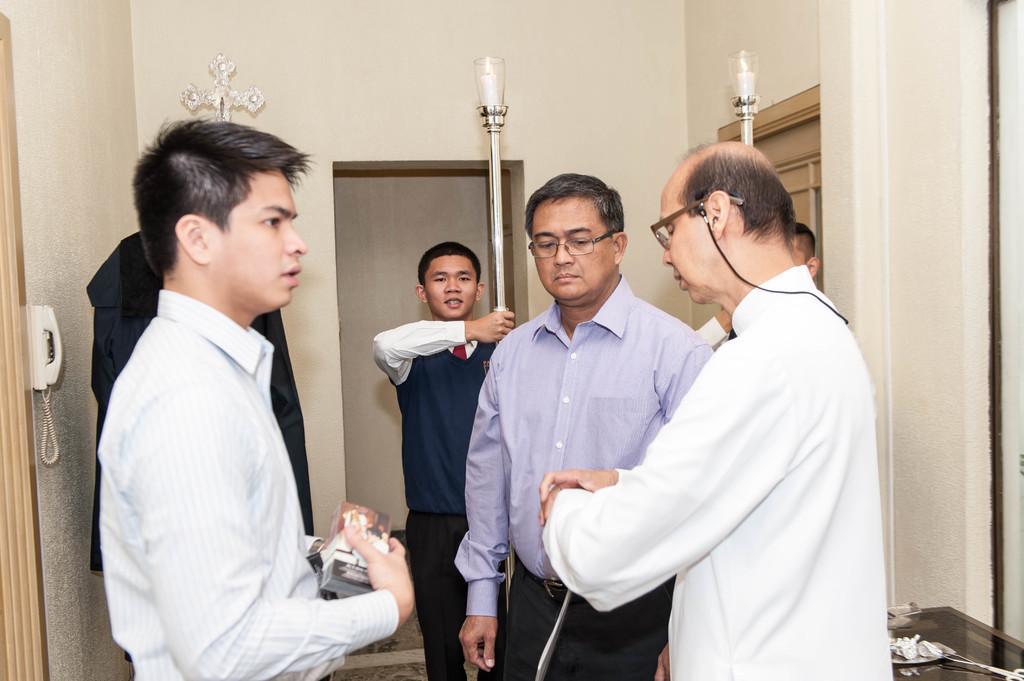Can you describe this image briefly? In this image we can see a few people, among them, some are holding the objects, also we can see a door, window, landline phone and a table with some objects on it, also we can see the wall. 